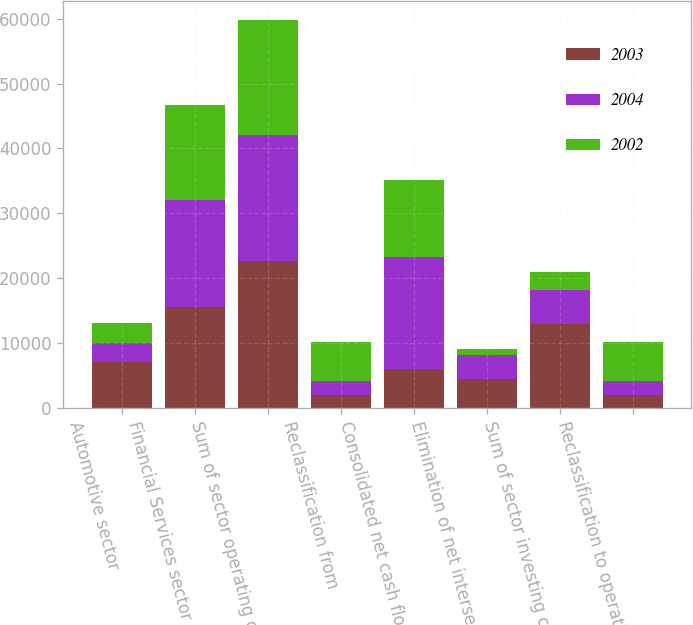<chart> <loc_0><loc_0><loc_500><loc_500><stacked_bar_chart><ecel><fcel>Automotive sector<fcel>Financial Services sector<fcel>Sum of sector operating cash<fcel>Reclassification from<fcel>Consolidated net cash flows<fcel>Elimination of net intersector<fcel>Sum of sector investing cash<fcel>Reclassification to operating<nl><fcel>2003<fcel>6998<fcel>15593<fcel>22591<fcel>1923<fcel>6023<fcel>4361<fcel>12928<fcel>1923<nl><fcel>2004<fcel>2948<fcel>16486<fcel>19434<fcel>2154<fcel>17280<fcel>3708<fcel>5156<fcel>2154<nl><fcel>2002<fcel>3099<fcel>14663<fcel>17762<fcel>6023<fcel>11739<fcel>1053<fcel>2871<fcel>6023<nl></chart> 